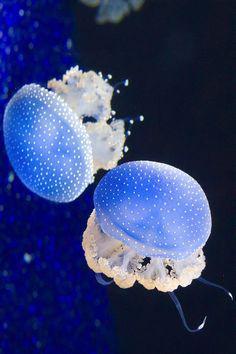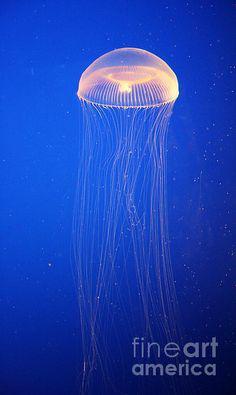The first image is the image on the left, the second image is the image on the right. Examine the images to the left and right. Is the description "The left image contains one jellyfish with a mushroom shaped cap facing rightside up and stringlike tentacles trailing down from it, and the right image includes a jellyfish with red-orange dots around the rim of its cap." accurate? Answer yes or no. No. The first image is the image on the left, the second image is the image on the right. Analyze the images presented: Is the assertion "There are two jellyfish in one image and one in the other image." valid? Answer yes or no. Yes. 